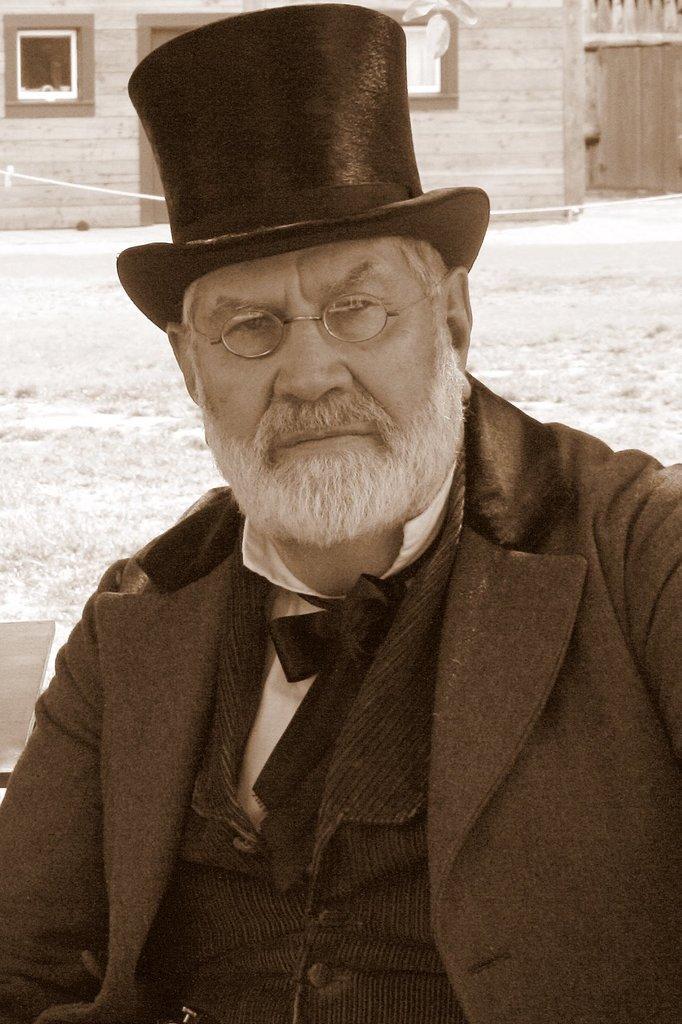Could you give a brief overview of what you see in this image? In this picture we can see a man wore a spectacle, cap, blazer, bow tie and at the back of him we can see the grass, house with windows, wall. 